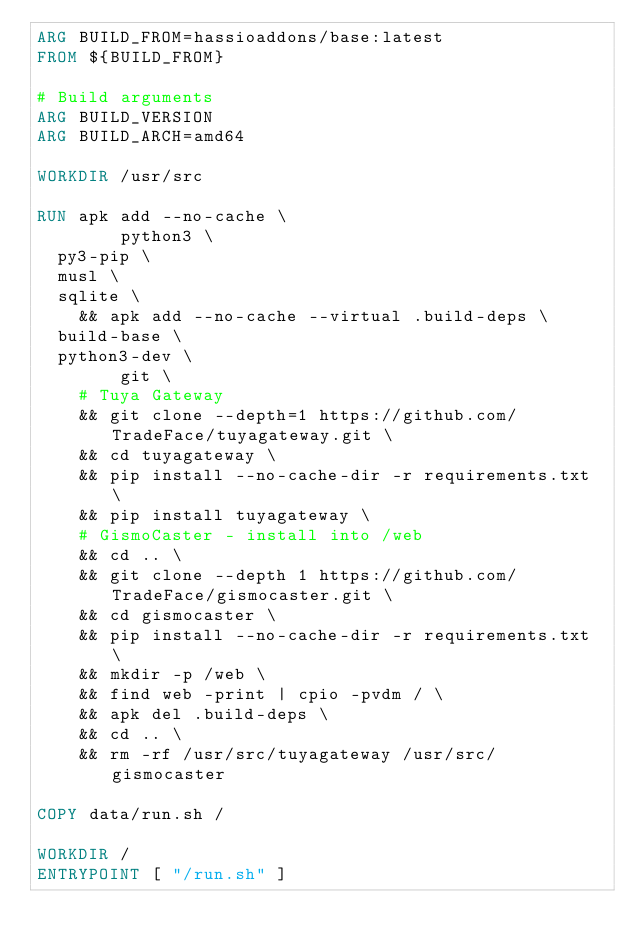Convert code to text. <code><loc_0><loc_0><loc_500><loc_500><_Dockerfile_>ARG BUILD_FROM=hassioaddons/base:latest
FROM ${BUILD_FROM}

# Build arguments
ARG BUILD_VERSION
ARG BUILD_ARCH=amd64

WORKDIR /usr/src

RUN apk add --no-cache \
        python3 \
	py3-pip \
	musl \
	sqlite \
    && apk add --no-cache --virtual .build-deps \
	build-base \
	python3-dev \
        git \
    # Tuya Gateway
    && git clone --depth=1 https://github.com/TradeFace/tuyagateway.git \
    && cd tuyagateway \ 
    && pip install --no-cache-dir -r requirements.txt \
    && pip install tuyagateway \
    # GismoCaster - install into /web
    && cd .. \
    && git clone --depth 1 https://github.com/TradeFace/gismocaster.git \
    && cd gismocaster \
    && pip install --no-cache-dir -r requirements.txt \
    && mkdir -p /web \
    && find web -print | cpio -pvdm / \
    && apk del .build-deps \
    && cd .. \
    && rm -rf /usr/src/tuyagateway /usr/src/gismocaster

COPY data/run.sh /

WORKDIR /
ENTRYPOINT [ "/run.sh" ]
</code> 